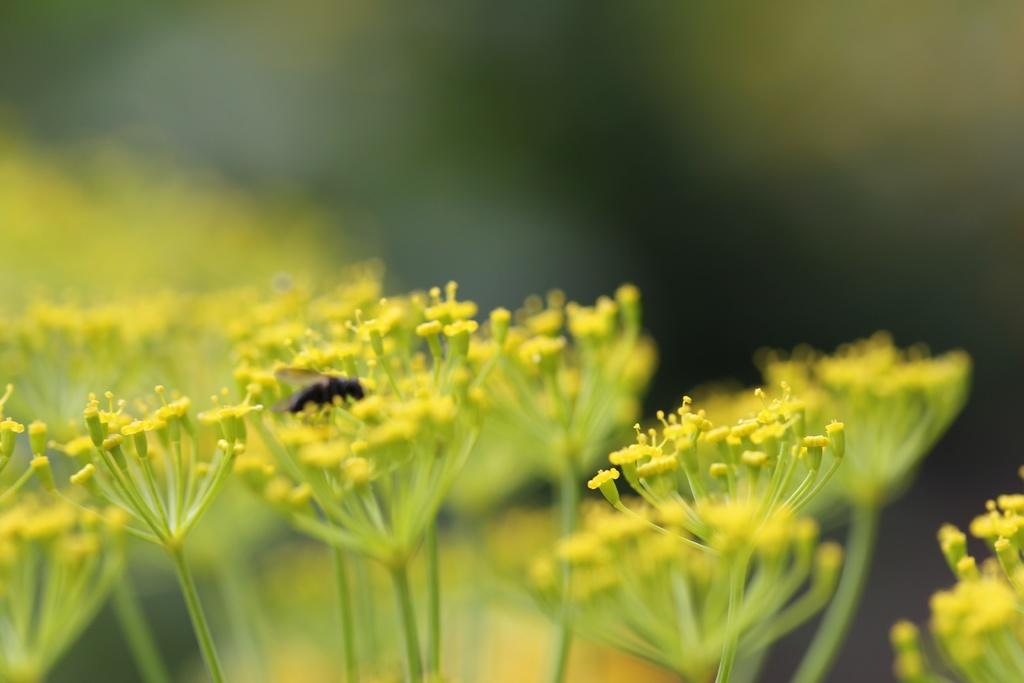What is the main subject in the center of the image? There is an insect in the center of the image. What type of vegetation is present at the bottom of the image? There are flowers and plants at the bottom of the image. How would you describe the background of the image? The background of the image is blurry. Can you tell me how many mothers are visible in the image? There are no mothers present in the image; it features an insect and plants. What type of frogs can be seen interacting with the insect in the image? There are no frogs present in the image; it only features an insect and plants. 